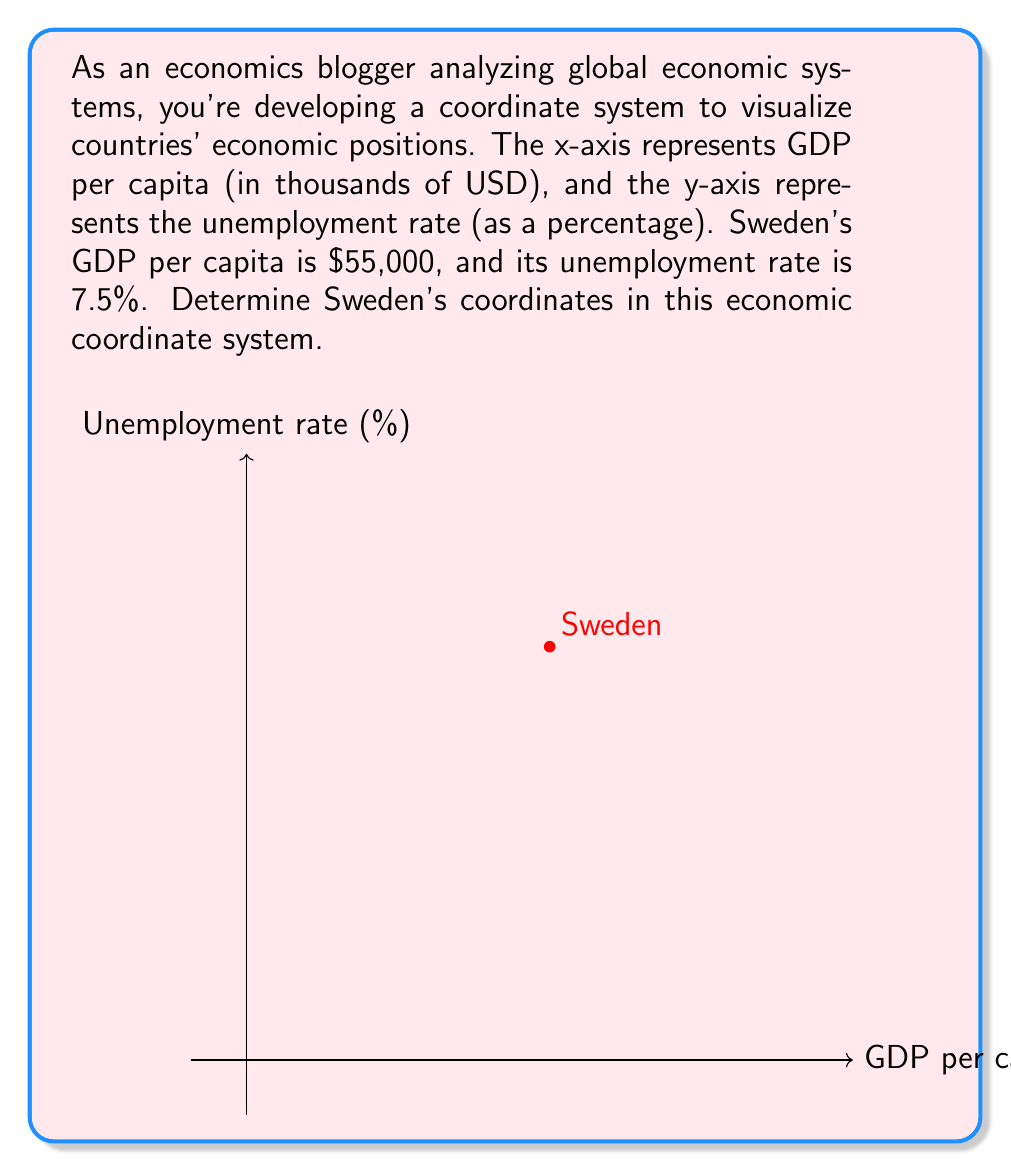What is the answer to this math problem? To determine Sweden's coordinates in the given economic coordinate system, we need to convert the given information into the appropriate units for each axis:

1. For the x-axis (GDP per capita):
   - Given: $55,000 USD
   - Required unit: thousands of USD
   - Conversion: $55,000 \div 1,000 = 55$
   
   So, the x-coordinate is 55.

2. For the y-axis (Unemployment rate):
   - Given: 7.5%
   - Required unit: percentage
   - No conversion needed
   
   So, the y-coordinate is 7.5.

Therefore, Sweden's position in this economic coordinate system is represented by the point (55, 7.5).

In the coordinate notation, this is written as:

$$(x, y) = (55, 7.5)$$

where $x$ represents the GDP per capita in thousands of USD, and $y$ represents the unemployment rate as a percentage.
Answer: (55, 7.5) 